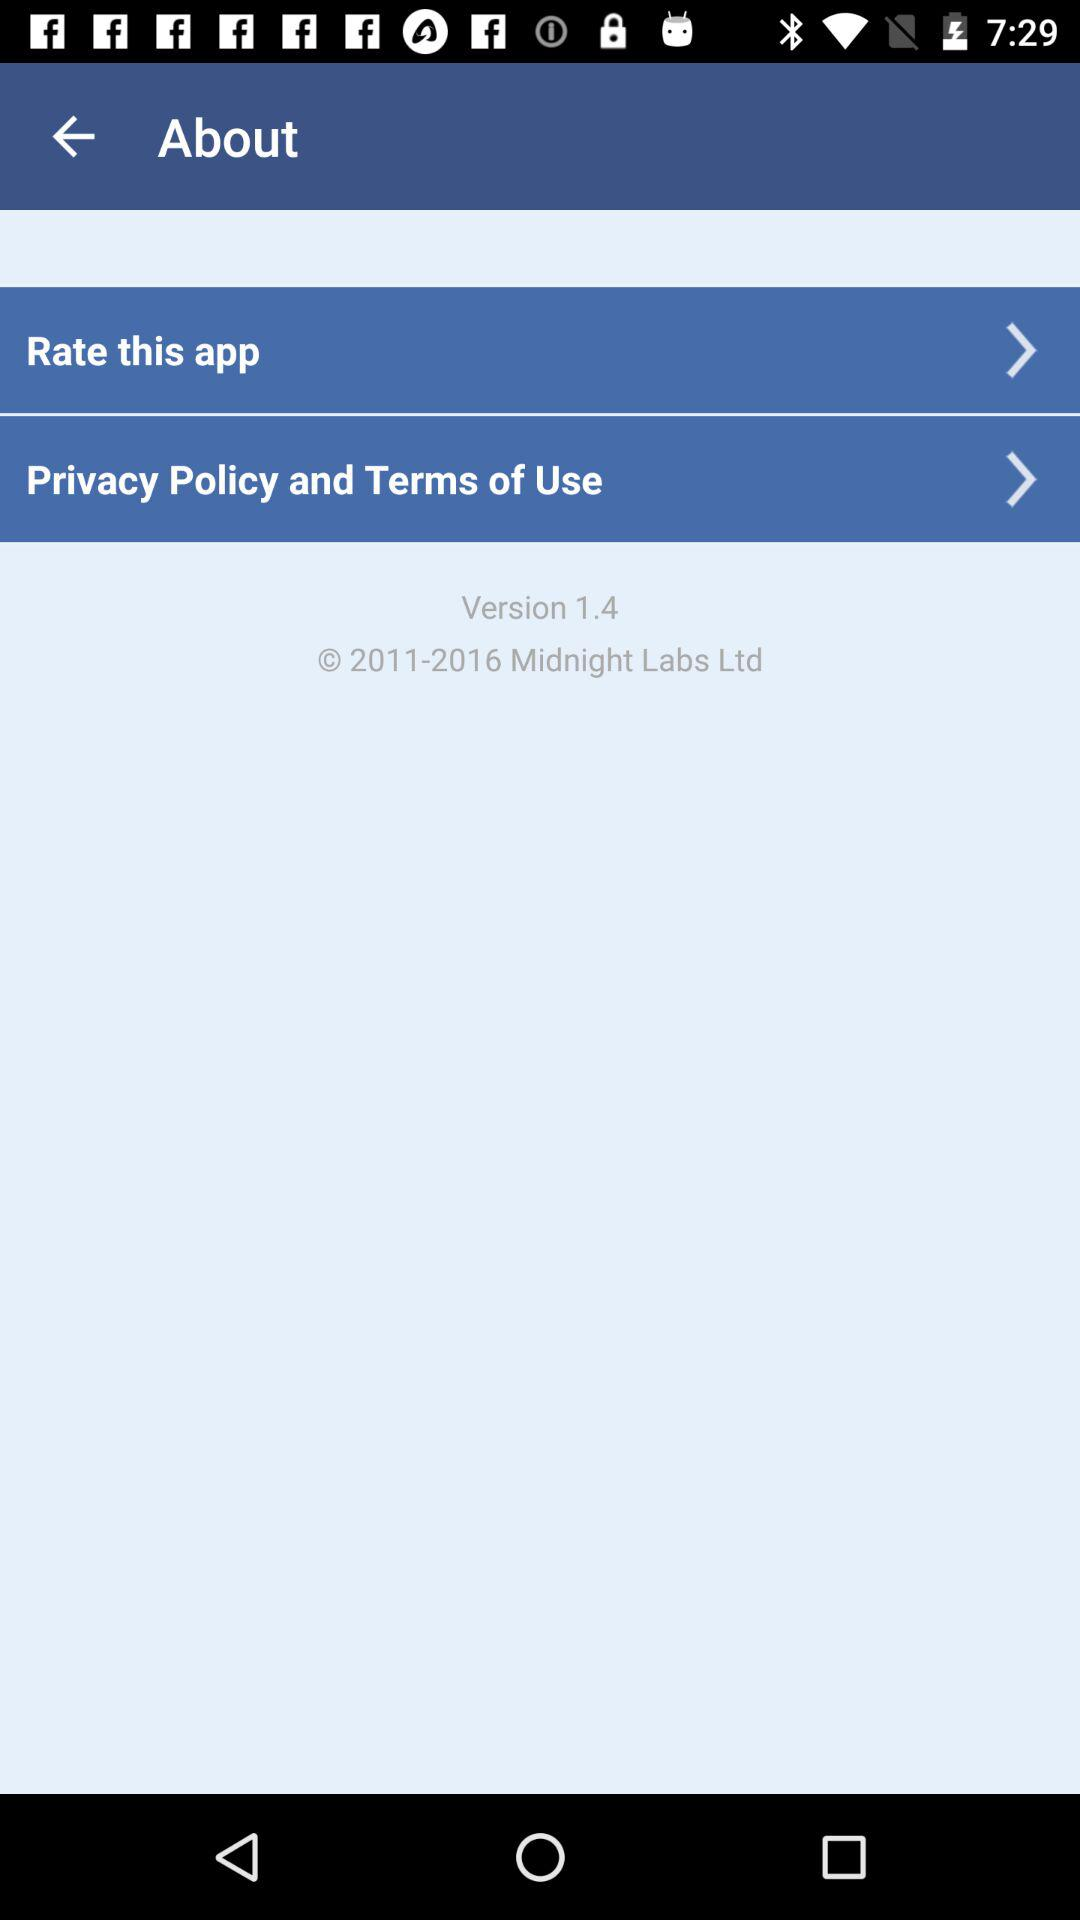Which option is selected?
When the provided information is insufficient, respond with <no answer>. <no answer> 